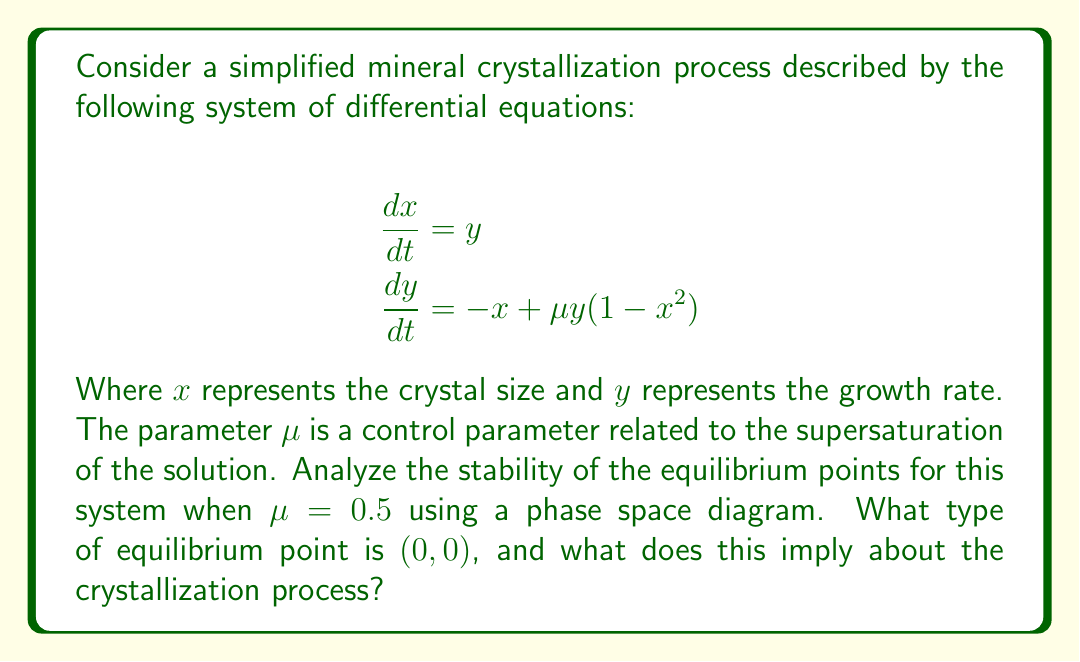Solve this math problem. 1. First, we need to find the equilibrium points of the system. Set both equations to zero:

   $$y = 0$$
   $$-x + \mu y(1-x^2) = 0$$

   Substituting $y=0$ into the second equation, we get $x=0$. So, (0,0) is an equilibrium point.

2. To analyze the stability of (0,0), we need to calculate the Jacobian matrix at this point:

   $$J = \begin{bmatrix}
   \frac{\partial \dot{x}}{\partial x} & \frac{\partial \dot{x}}{\partial y} \\
   \frac{\partial \dot{y}}{\partial x} & \frac{\partial \dot{y}}{\partial y}
   \end{bmatrix} = \begin{bmatrix}
   0 & 1 \\
   -1 + \mu y(-2x) & \mu(1-x^2)
   \end{bmatrix}$$

   At (0,0), this becomes:

   $$J_{(0,0)} = \begin{bmatrix}
   0 & 1 \\
   -1 & \mu
   \end{bmatrix} = \begin{bmatrix}
   0 & 1 \\
   -1 & 0.5
   \end{bmatrix}$$

3. Calculate the eigenvalues of $J_{(0,0)}$:

   $$\det(J_{(0,0)} - \lambda I) = \begin{vmatrix}
   -\lambda & 1 \\
   -1 & 0.5-\lambda
   \end{vmatrix} = \lambda^2 - 0.5\lambda + 1 = 0$$

   Solving this characteristic equation:

   $$\lambda = \frac{0.5 \pm \sqrt{0.25 - 4}}{2} = 0.25 \pm 0.9682i$$

4. Since the eigenvalues are complex conjugates with positive real parts, (0,0) is an unstable spiral point.

5. To visualize this, we can sketch a phase space diagram:

   [asy]
   import graph;
   size(200);
   
   void vector(real x, real y) {
     real dx = y;
     real dy = -x + 0.5*y*(1-x^2);
     real l = sqrt(dx^2+dy^2);
     draw((x,y)--(x+0.15*dx/l,y+0.15*dy/l),Arrow);
   }
   
   for(int i = -4; i <= 4; ++i)
     for(int j = -4; j <= 4; ++j)
       vector(0.5*i,0.5*j);
   
   dot((0,0));
   label("(0,0)", (0,0), SE);
   
   xaxis("x", arrow=Arrow);
   yaxis("y", arrow=Arrow);
   [/asy]

6. The phase space diagram shows trajectories spiraling outward from (0,0), confirming it is an unstable spiral point.

For the crystallization process, this implies that small perturbations from the equilibrium will cause the crystal size and growth rate to oscillate with increasing amplitude over time, leading to unstable growth.
Answer: Unstable spiral point, implying oscillatory and unstable crystal growth. 